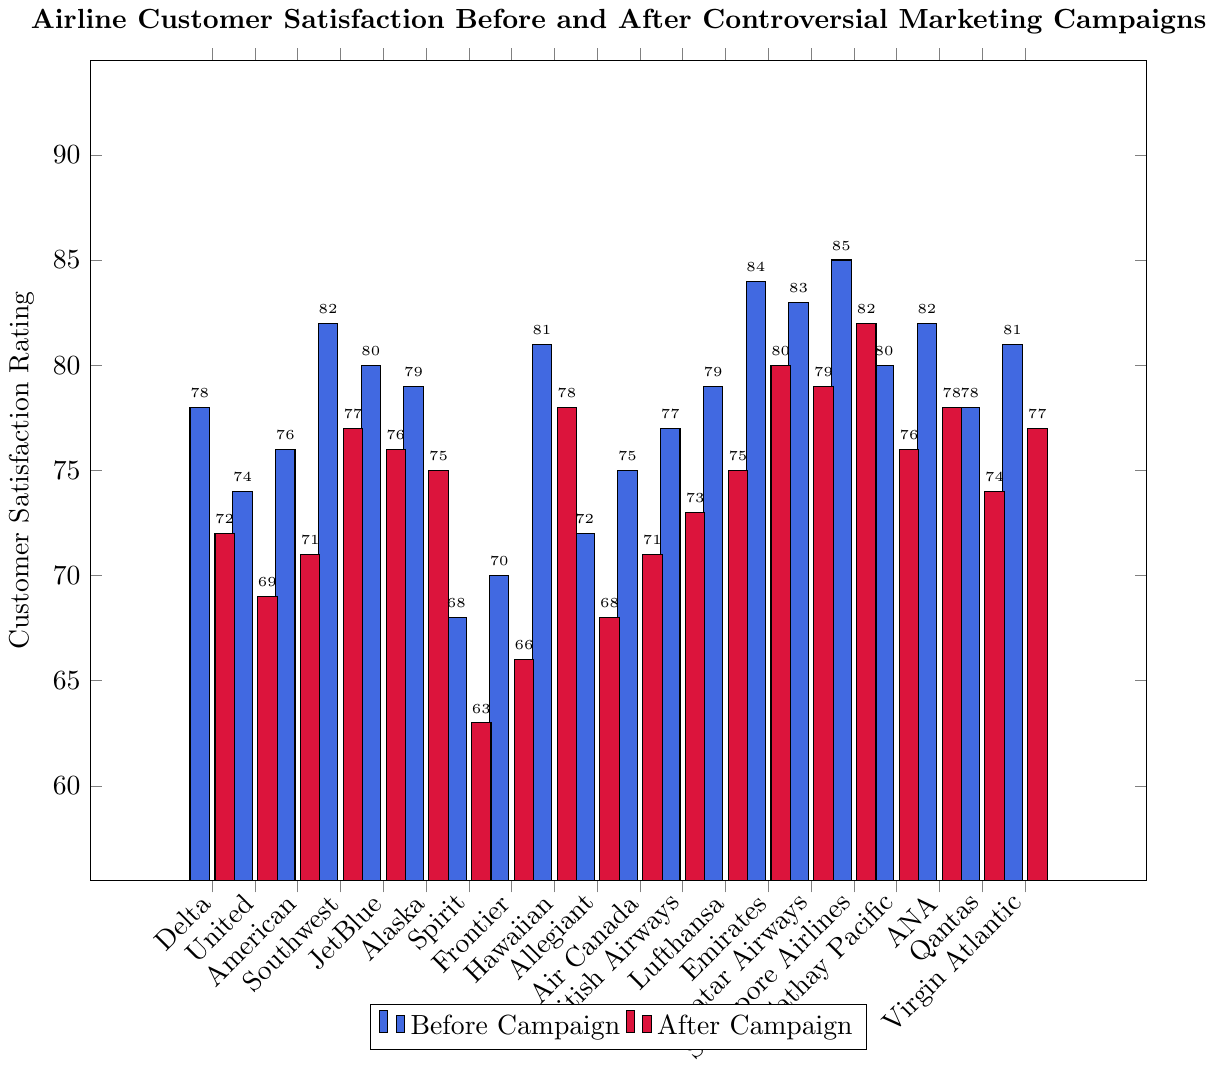Which airline had the highest customer satisfaction rating before the campaign? The highest customer satisfaction rating before the campaign can be identified by looking for the tallest blue bar in the chart. Singapore Airlines has the tallest blue bar at a rating of 85.
Answer: Singapore Airlines Which airline had the greatest decrease in customer satisfaction after the campaign? To find the greatest decrease, calculate the difference between the 'Before Campaign' and 'After Campaign' ratings for each airline. The difference is largest for Spirit (68 - 63 = 5).
Answer: Spirit What is the average customer satisfaction rating after the campaign for all airlines? Sum the 'After Campaign' ratings for all airlines and divide by the number of airlines. The total after the campaign is 72 + 69 + 71 + 77 + 76 + 75 + 63 + 66 + 78 + 68 + 71 + 73 + 75 + 80 + 79 + 82 + 76 + 78 + 74 + 77 = 1440. There are 20 airlines, so the average is 1440 / 20 = 72.
Answer: 72 Did any airline have its customer satisfaction rating improve after the campaign? By comparing the heights of the blue and red bars for each airline, we see that no airline's red bar is higher than its blue bar, meaning no airline had an improvement in customer satisfaction after the campaign.
Answer: No Which airline had the smallest decrease in customer satisfaction after the campaign? Calculate the difference between 'Before Campaign' and 'After Campaign' ratings for each airline, and identify the smallest difference. Hawaiian had a decrease of 81 - 78 = 3.
Answer: Hawaiian What is the difference in customer satisfaction ratings for Emirates and Delta before and after the campaign? For Delta, the before rating is 78 and the after rating is 72, so the difference is 78 - 72 = 6. For Emirates, the before rating is 84 and the after rating is 80, so the difference is 84 - 80 = 4.
Answer: Delta: 6, Emirates: 4 Which airline showed a customer satisfaction rating of 80 before the campaign and how much did this rating change after the campaign? Locate the blue bars that equal 80. JetBlue and Cathay Pacific both have a rating of 80 before the campaign. After the campaign, both ratings changed to 76. The rating change for both is 80 - 76 = 4.
Answer: JetBlue and Cathay Pacific, 4 What is the difference in customer satisfaction ratings between the highest and lowest rated airlines before the campaign? The highest rating before the campaign is for Singapore Airlines (85), and the lowest is for Spirit (68). The difference is 85 - 68 = 17.
Answer: 17 How many airlines had a customer satisfaction rating of 75 or above after the campaign? Identify the red bars that are 75 or higher. There are 8 such airlines: Hawaiian, Singapore Airlines, Emirates, Qatar Airways, Lufthansa, ANA, JetBlue, Alaska (all with 75 or higher after the campaign).
Answer: 8 